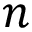<formula> <loc_0><loc_0><loc_500><loc_500>n</formula> 